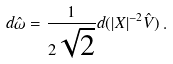<formula> <loc_0><loc_0><loc_500><loc_500>d \hat { \omega } = \frac { 1 } { 2 \sqrt { 2 } } d ( | X | ^ { - 2 } \hat { V } ) \, .</formula> 